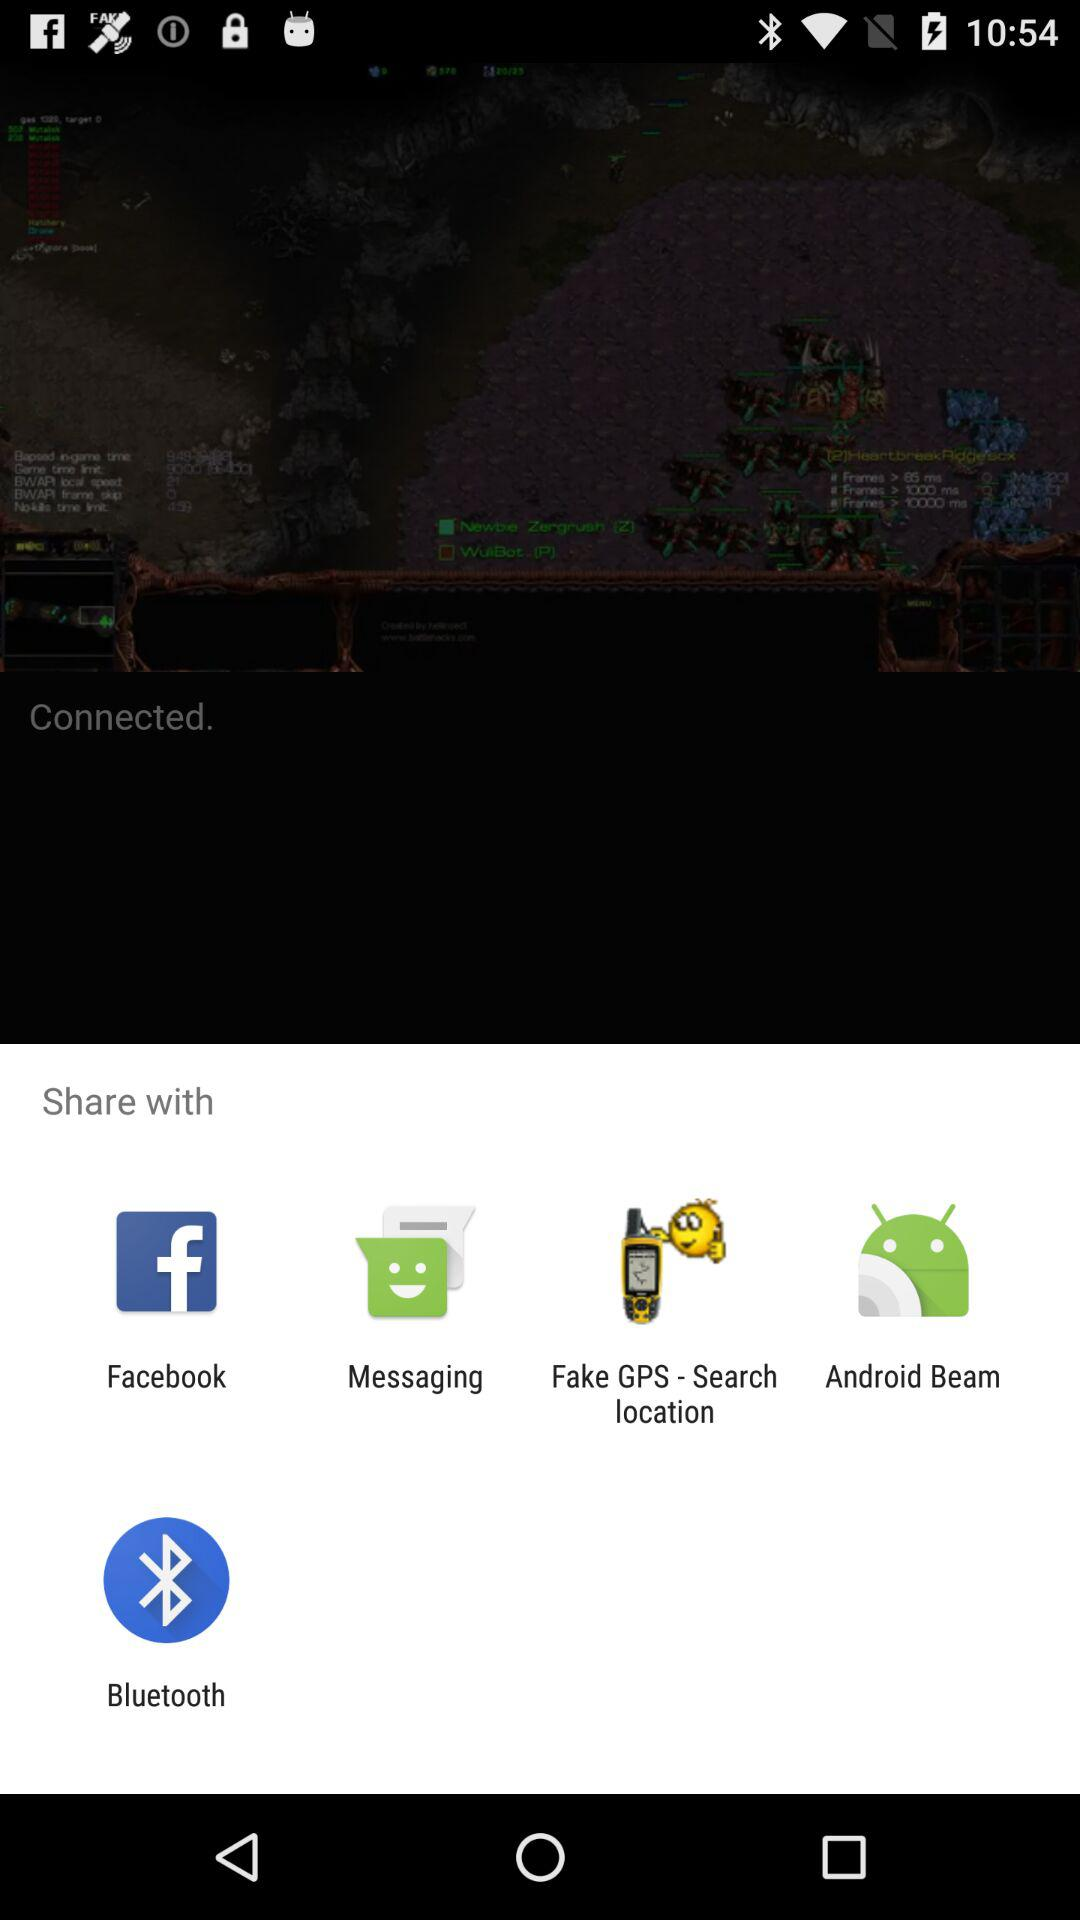Who is connected?
When the provided information is insufficient, respond with <no answer>. <no answer> 